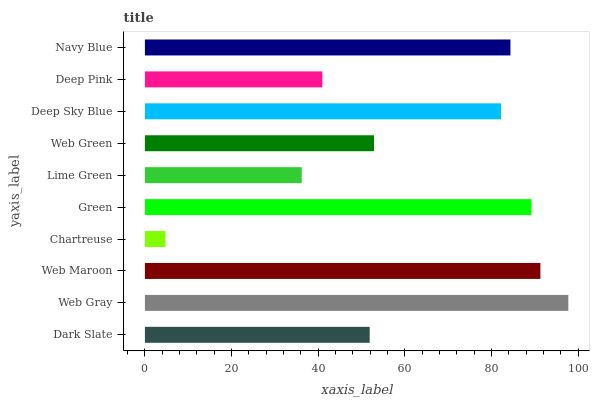Is Chartreuse the minimum?
Answer yes or no. Yes. Is Web Gray the maximum?
Answer yes or no. Yes. Is Web Maroon the minimum?
Answer yes or no. No. Is Web Maroon the maximum?
Answer yes or no. No. Is Web Gray greater than Web Maroon?
Answer yes or no. Yes. Is Web Maroon less than Web Gray?
Answer yes or no. Yes. Is Web Maroon greater than Web Gray?
Answer yes or no. No. Is Web Gray less than Web Maroon?
Answer yes or no. No. Is Deep Sky Blue the high median?
Answer yes or no. Yes. Is Web Green the low median?
Answer yes or no. Yes. Is Chartreuse the high median?
Answer yes or no. No. Is Green the low median?
Answer yes or no. No. 